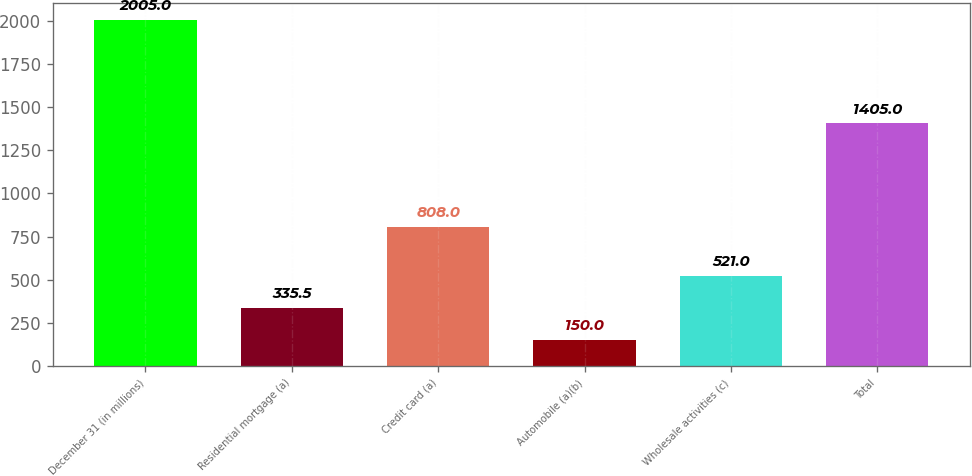Convert chart. <chart><loc_0><loc_0><loc_500><loc_500><bar_chart><fcel>December 31 (in millions)<fcel>Residential mortgage (a)<fcel>Credit card (a)<fcel>Automobile (a)(b)<fcel>Wholesale activities (c)<fcel>Total<nl><fcel>2005<fcel>335.5<fcel>808<fcel>150<fcel>521<fcel>1405<nl></chart> 